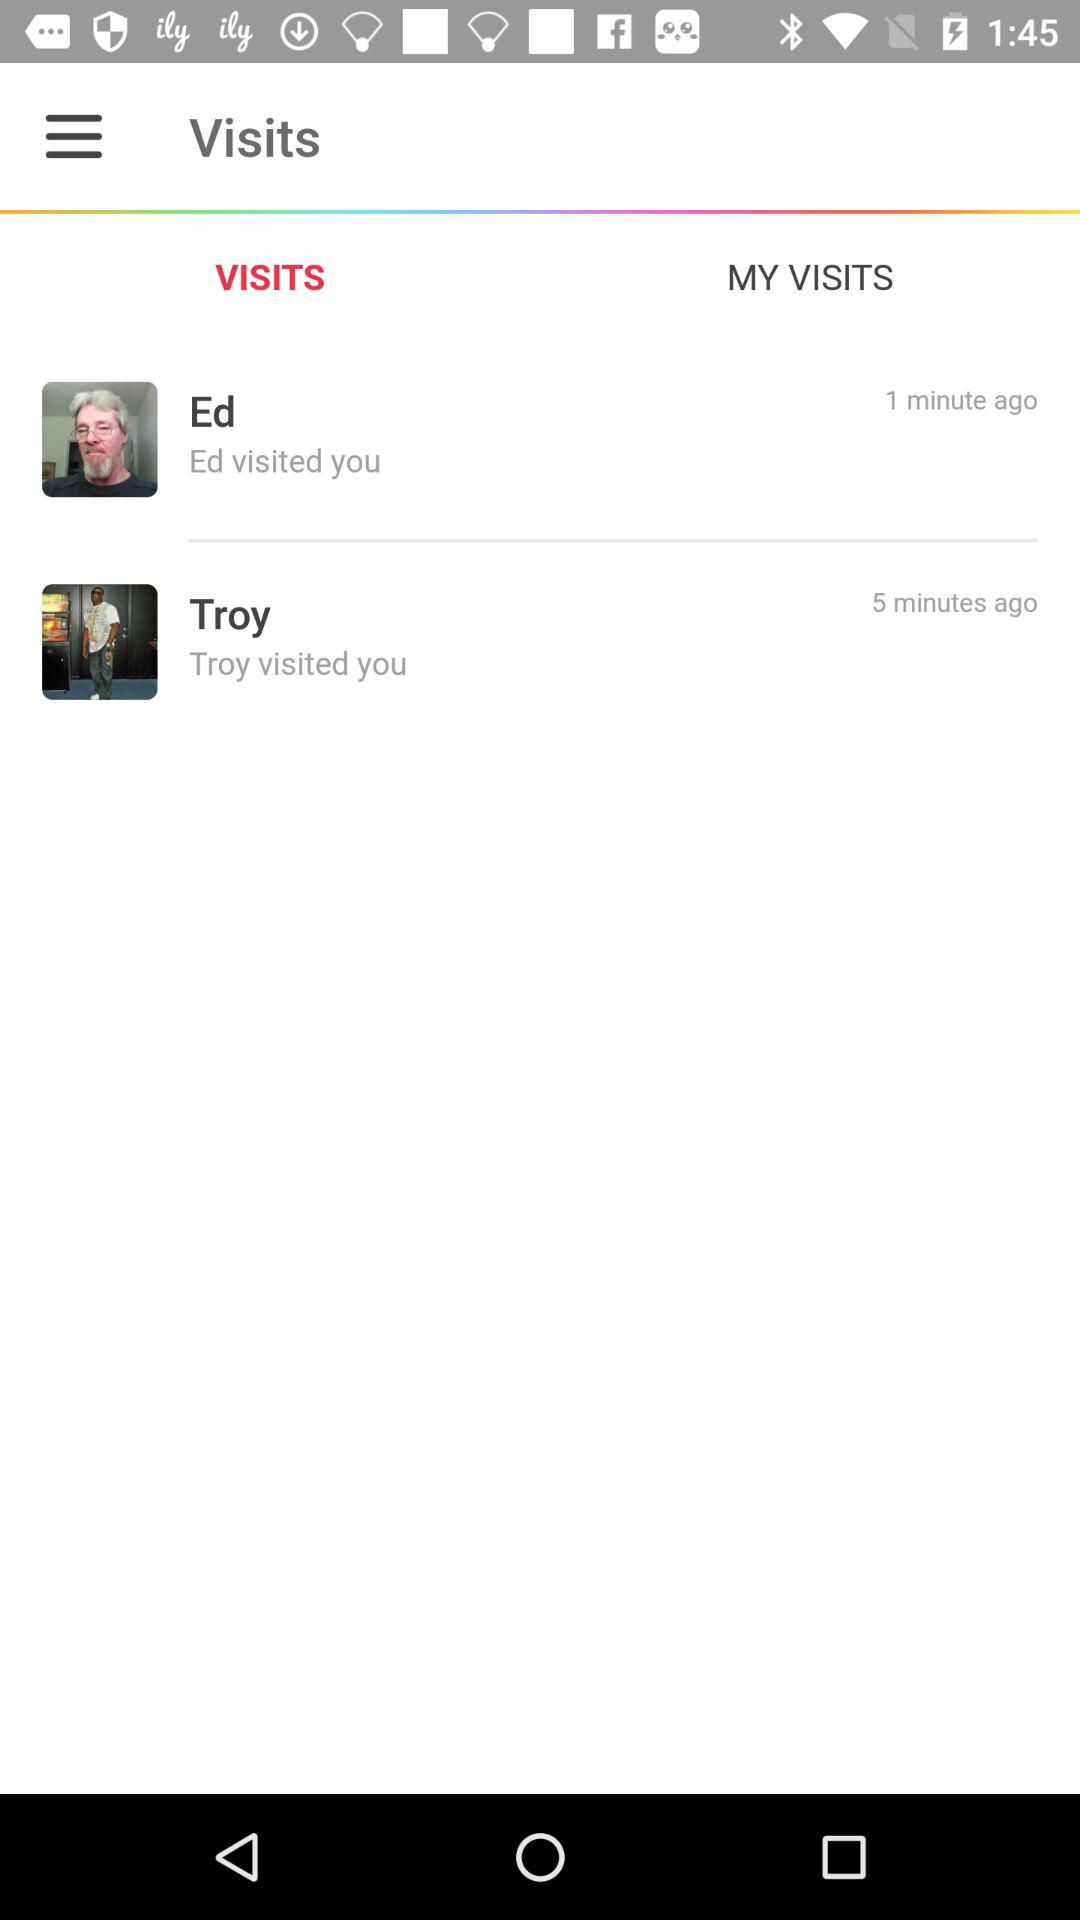Which tab is currently selected? The selected tab is "VISITS". 